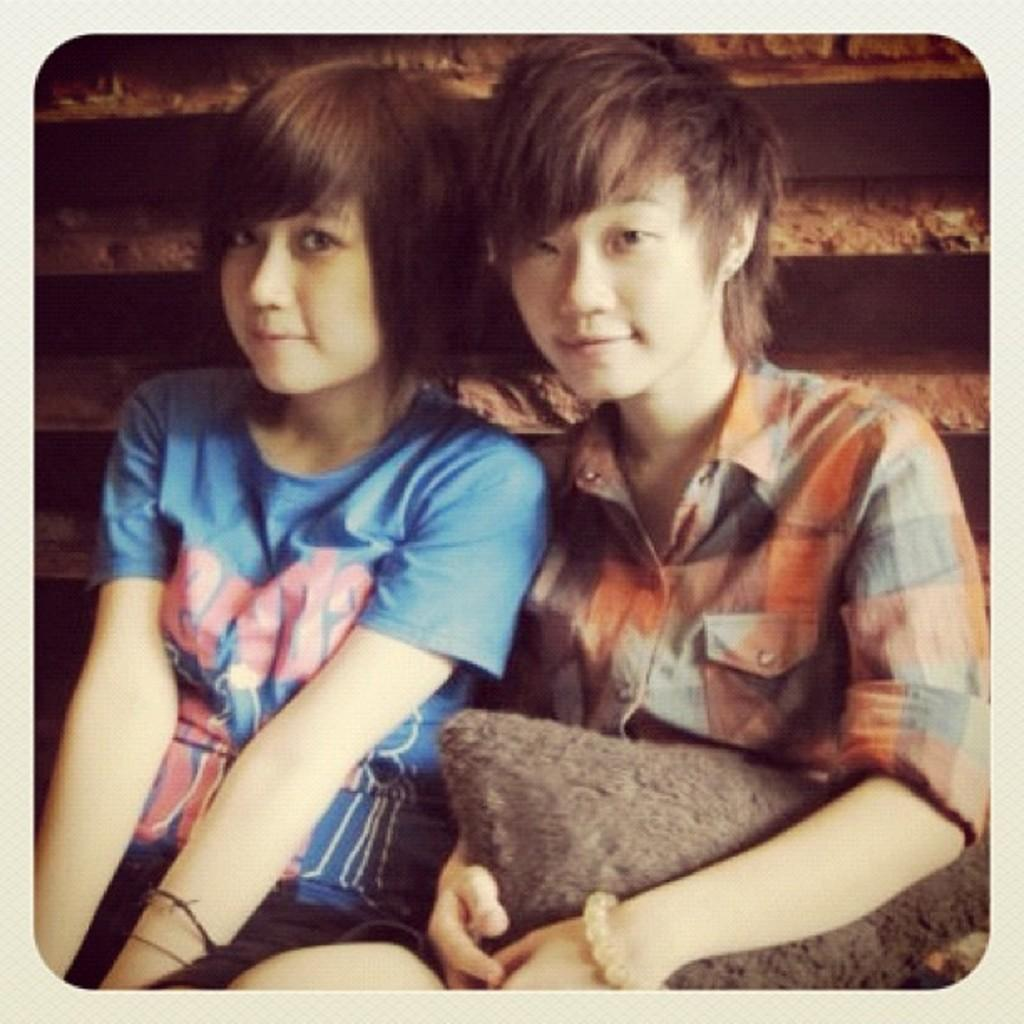How many people are in the image? There are two women in the image. What are the women doing in the image? Both women are sitting. Can you describe what one of the women is holding? One of the women is holding a pillow. What type of robin can be seen perched on the woman's shoulder in the image? There is no robin present in the image; it only features two women, both of whom are sitting. 